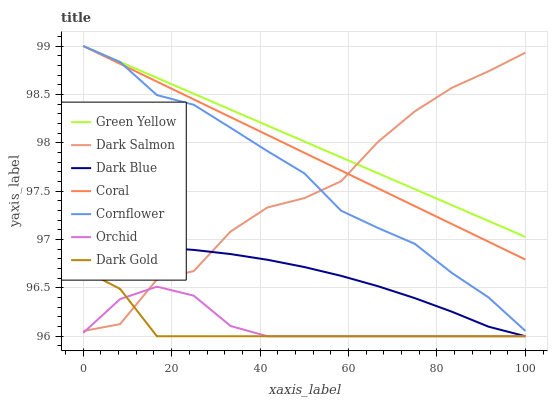Does Dark Gold have the minimum area under the curve?
Answer yes or no. Yes. Does Green Yellow have the maximum area under the curve?
Answer yes or no. Yes. Does Coral have the minimum area under the curve?
Answer yes or no. No. Does Coral have the maximum area under the curve?
Answer yes or no. No. Is Coral the smoothest?
Answer yes or no. Yes. Is Dark Salmon the roughest?
Answer yes or no. Yes. Is Dark Gold the smoothest?
Answer yes or no. No. Is Dark Gold the roughest?
Answer yes or no. No. Does Dark Gold have the lowest value?
Answer yes or no. Yes. Does Coral have the lowest value?
Answer yes or no. No. Does Green Yellow have the highest value?
Answer yes or no. Yes. Does Dark Gold have the highest value?
Answer yes or no. No. Is Orchid less than Green Yellow?
Answer yes or no. Yes. Is Coral greater than Dark Gold?
Answer yes or no. Yes. Does Dark Salmon intersect Dark Blue?
Answer yes or no. Yes. Is Dark Salmon less than Dark Blue?
Answer yes or no. No. Is Dark Salmon greater than Dark Blue?
Answer yes or no. No. Does Orchid intersect Green Yellow?
Answer yes or no. No. 